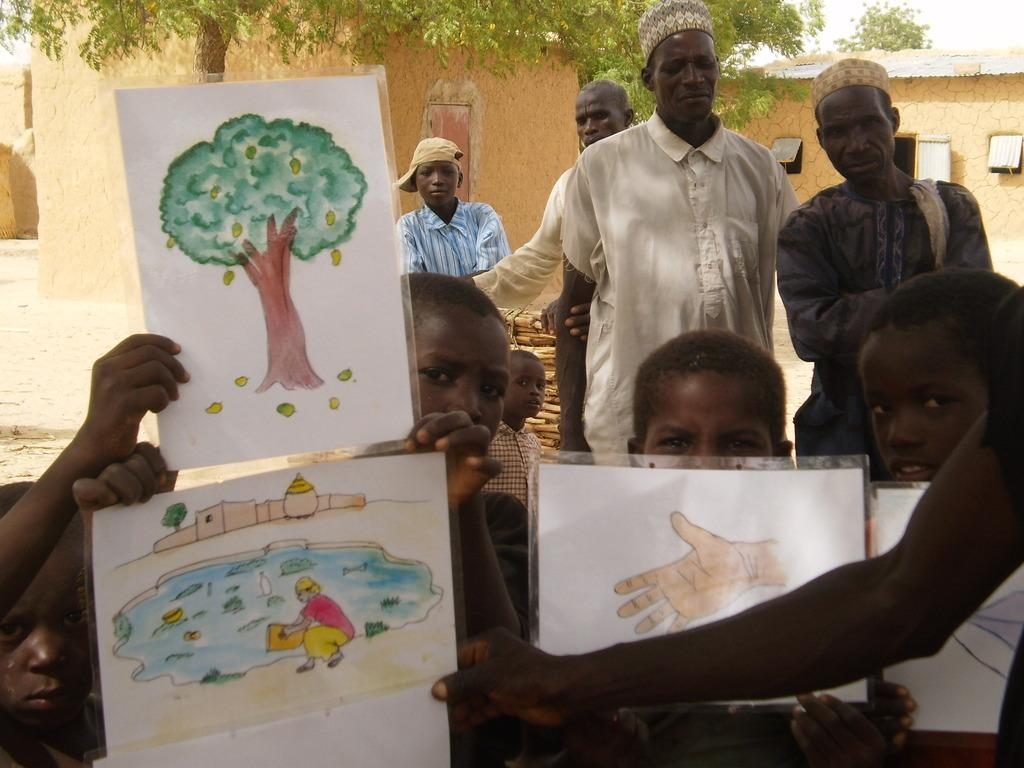What are the kids in the image holding? The kids in the center of the image are holding paintings. What can be seen in the background of the image? There are houses, a group of people, a tree, and the sky visible in the background of the image. What type of twig can be seen in the hands of the kids in the image? There is no twig present in the hands of the kids in the image; they are holding paintings. How many legs are visible in the image? The provided facts do not mention the number of legs visible in the image, so it cannot be determined from the information given. 